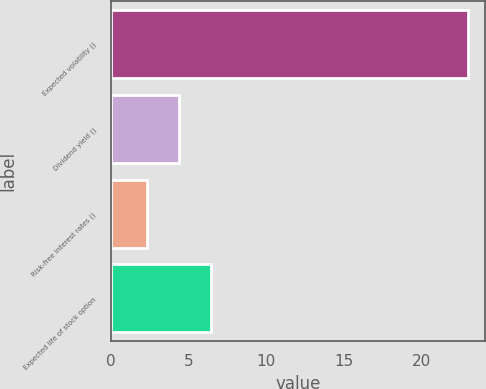Convert chart to OTSL. <chart><loc_0><loc_0><loc_500><loc_500><bar_chart><fcel>Expected volatility ()<fcel>Dividend yield ()<fcel>Risk-free interest rates ()<fcel>Expected life of stock option<nl><fcel>22.94<fcel>4.37<fcel>2.31<fcel>6.43<nl></chart> 